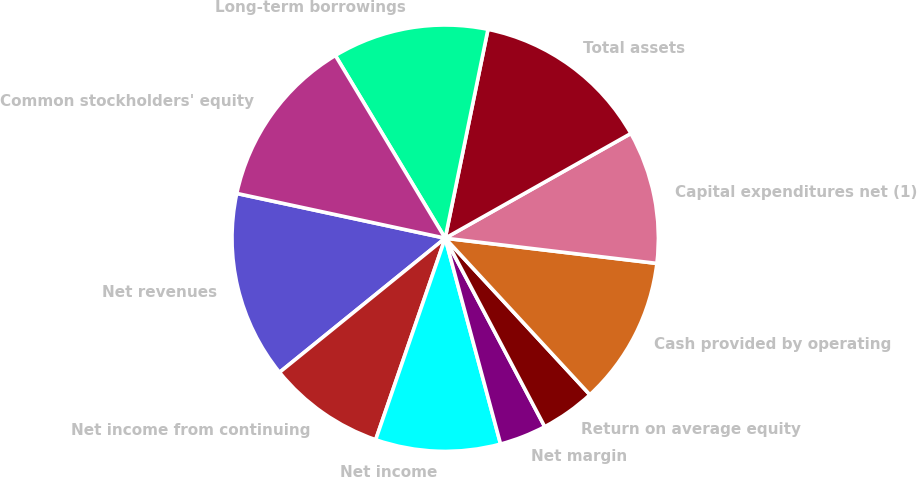<chart> <loc_0><loc_0><loc_500><loc_500><pie_chart><fcel>Net revenues<fcel>Net income from continuing<fcel>Net income<fcel>Net margin<fcel>Return on average equity<fcel>Cash provided by operating<fcel>Capital expenditures net (1)<fcel>Total assets<fcel>Long-term borrowings<fcel>Common stockholders' equity<nl><fcel>14.2%<fcel>8.88%<fcel>9.47%<fcel>3.55%<fcel>4.14%<fcel>11.24%<fcel>10.06%<fcel>13.61%<fcel>11.83%<fcel>13.02%<nl></chart> 